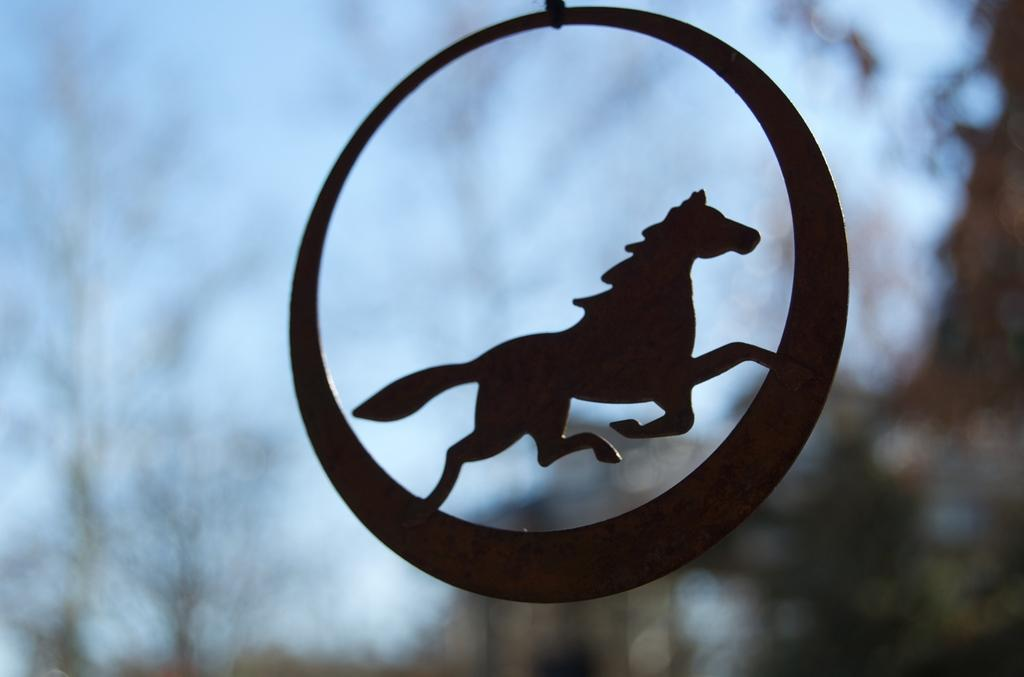What shape is the main object in the image? The main object in the image is round. What is depicted on the round object? There is a horse depicted on the round object. Can you describe the background of the image? The background of the image is blurry. What type of request is the boy making in the image? There is no boy present in the image, and therefore no request can be observed. 